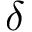<formula> <loc_0><loc_0><loc_500><loc_500>\delta</formula> 